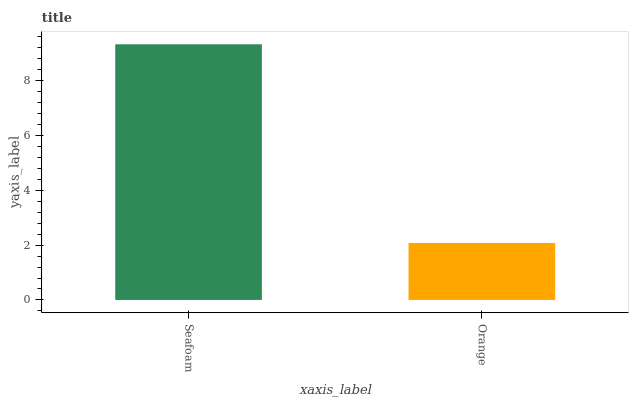Is Orange the minimum?
Answer yes or no. Yes. Is Seafoam the maximum?
Answer yes or no. Yes. Is Orange the maximum?
Answer yes or no. No. Is Seafoam greater than Orange?
Answer yes or no. Yes. Is Orange less than Seafoam?
Answer yes or no. Yes. Is Orange greater than Seafoam?
Answer yes or no. No. Is Seafoam less than Orange?
Answer yes or no. No. Is Seafoam the high median?
Answer yes or no. Yes. Is Orange the low median?
Answer yes or no. Yes. Is Orange the high median?
Answer yes or no. No. Is Seafoam the low median?
Answer yes or no. No. 